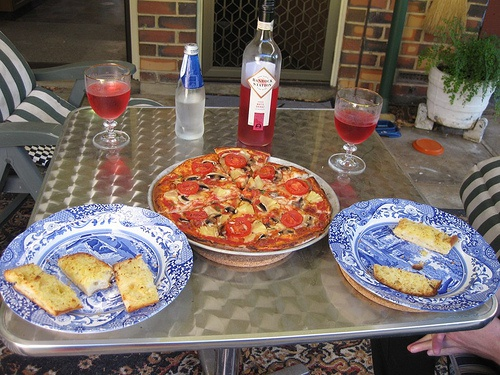Describe the objects in this image and their specific colors. I can see dining table in black, gray, darkgray, and lavender tones, chair in black, gray, darkgray, and purple tones, pizza in black, tan, red, and brown tones, potted plant in black, darkgreen, and darkgray tones, and bottle in black, lightgray, maroon, gray, and brown tones in this image. 